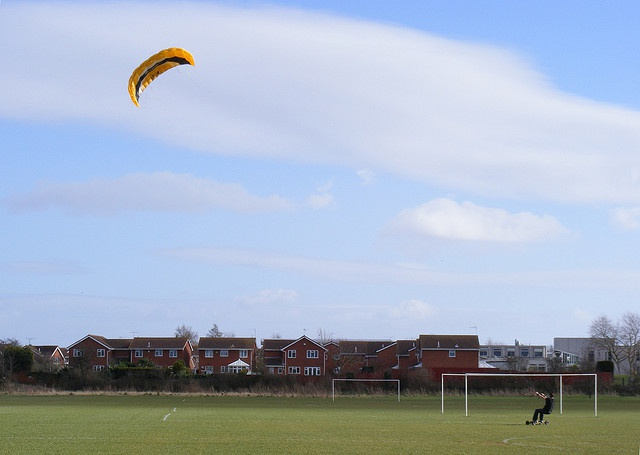Describe the objects in this image and their specific colors. I can see kite in lavender, olive, orange, and black tones and people in lavender, black, gray, and maroon tones in this image. 